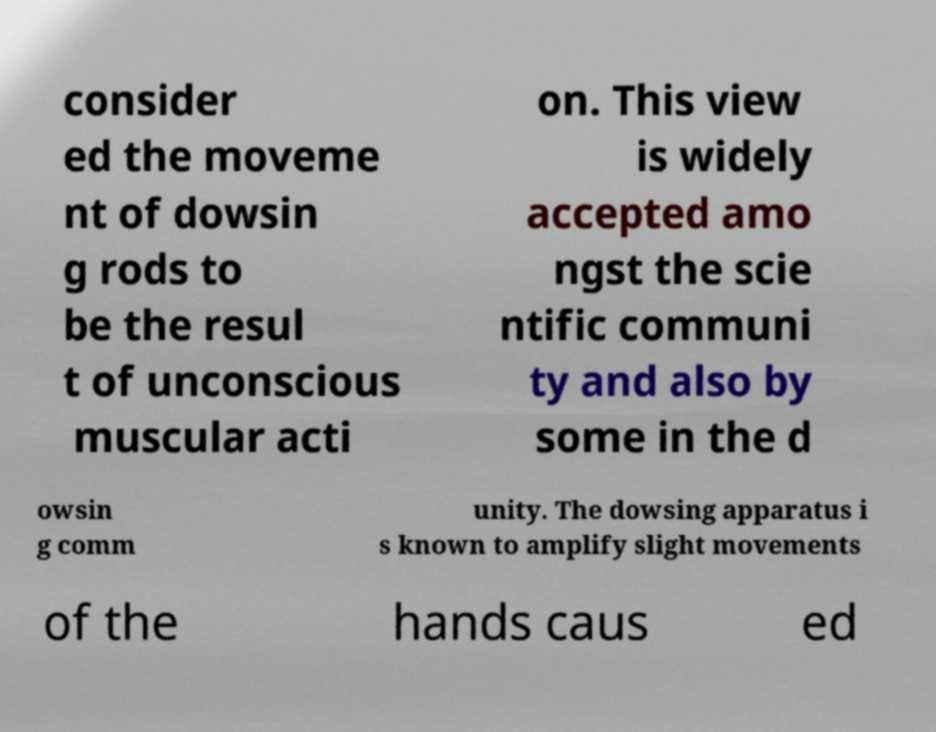There's text embedded in this image that I need extracted. Can you transcribe it verbatim? consider ed the moveme nt of dowsin g rods to be the resul t of unconscious muscular acti on. This view is widely accepted amo ngst the scie ntific communi ty and also by some in the d owsin g comm unity. The dowsing apparatus i s known to amplify slight movements of the hands caus ed 